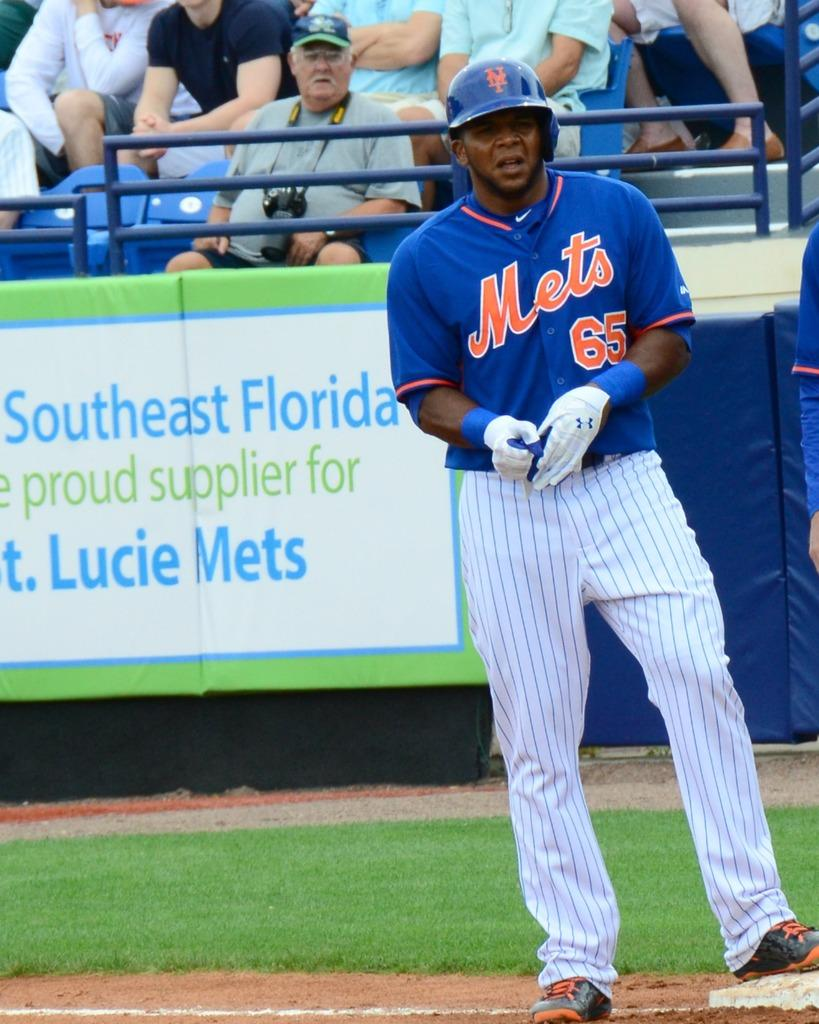<image>
Give a short and clear explanation of the subsequent image. the number 65 player of the Mets is on base 